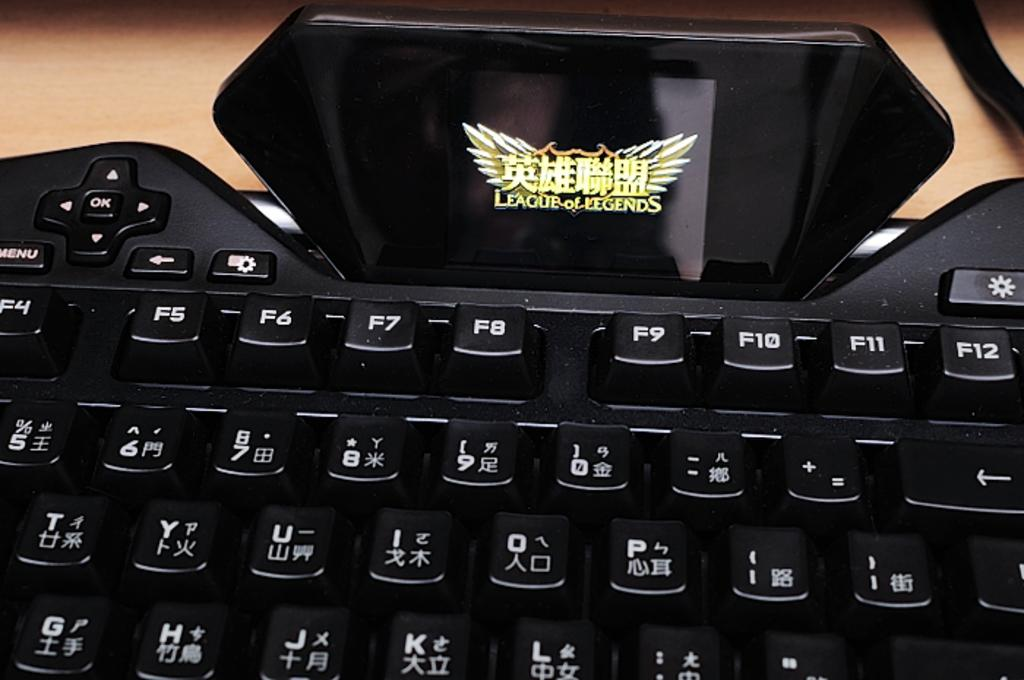<image>
Share a concise interpretation of the image provided. A League of Legends screen sits above a black keyboard. 